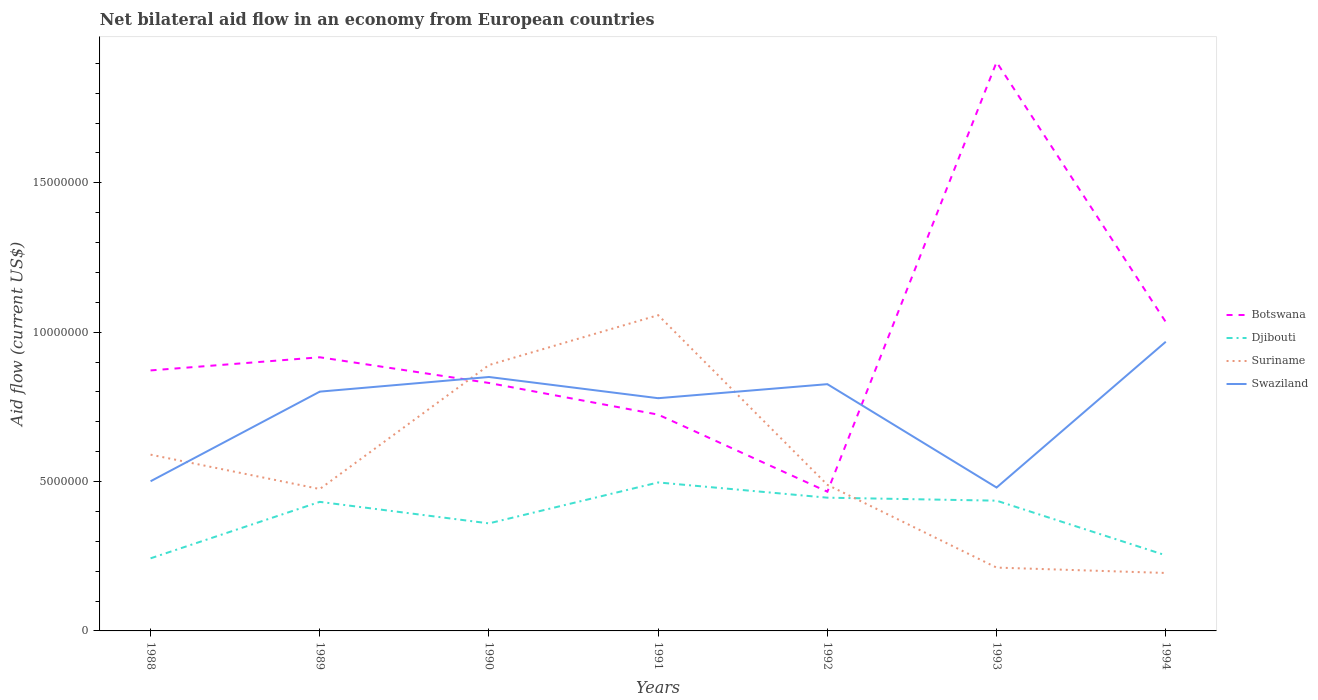How many different coloured lines are there?
Keep it short and to the point. 4. Does the line corresponding to Djibouti intersect with the line corresponding to Suriname?
Offer a terse response. Yes. Across all years, what is the maximum net bilateral aid flow in Suriname?
Offer a terse response. 1.94e+06. What is the total net bilateral aid flow in Djibouti in the graph?
Give a very brief answer. -1.93e+06. What is the difference between the highest and the second highest net bilateral aid flow in Swaziland?
Your answer should be very brief. 4.88e+06. Is the net bilateral aid flow in Djibouti strictly greater than the net bilateral aid flow in Swaziland over the years?
Your answer should be very brief. Yes. How many lines are there?
Offer a terse response. 4. How many years are there in the graph?
Keep it short and to the point. 7. Where does the legend appear in the graph?
Provide a succinct answer. Center right. How many legend labels are there?
Keep it short and to the point. 4. What is the title of the graph?
Make the answer very short. Net bilateral aid flow in an economy from European countries. What is the label or title of the X-axis?
Your answer should be compact. Years. What is the label or title of the Y-axis?
Provide a succinct answer. Aid flow (current US$). What is the Aid flow (current US$) in Botswana in 1988?
Your response must be concise. 8.72e+06. What is the Aid flow (current US$) in Djibouti in 1988?
Keep it short and to the point. 2.43e+06. What is the Aid flow (current US$) of Suriname in 1988?
Keep it short and to the point. 5.90e+06. What is the Aid flow (current US$) in Swaziland in 1988?
Your answer should be very brief. 5.01e+06. What is the Aid flow (current US$) of Botswana in 1989?
Your answer should be very brief. 9.16e+06. What is the Aid flow (current US$) in Djibouti in 1989?
Your response must be concise. 4.32e+06. What is the Aid flow (current US$) in Suriname in 1989?
Give a very brief answer. 4.75e+06. What is the Aid flow (current US$) of Swaziland in 1989?
Give a very brief answer. 8.01e+06. What is the Aid flow (current US$) in Botswana in 1990?
Your answer should be compact. 8.30e+06. What is the Aid flow (current US$) of Djibouti in 1990?
Provide a short and direct response. 3.60e+06. What is the Aid flow (current US$) in Suriname in 1990?
Your response must be concise. 8.90e+06. What is the Aid flow (current US$) of Swaziland in 1990?
Make the answer very short. 8.50e+06. What is the Aid flow (current US$) of Botswana in 1991?
Provide a succinct answer. 7.24e+06. What is the Aid flow (current US$) in Djibouti in 1991?
Offer a very short reply. 4.97e+06. What is the Aid flow (current US$) of Suriname in 1991?
Make the answer very short. 1.06e+07. What is the Aid flow (current US$) of Swaziland in 1991?
Your answer should be compact. 7.79e+06. What is the Aid flow (current US$) of Botswana in 1992?
Provide a short and direct response. 4.66e+06. What is the Aid flow (current US$) of Djibouti in 1992?
Offer a terse response. 4.46e+06. What is the Aid flow (current US$) in Suriname in 1992?
Your response must be concise. 4.89e+06. What is the Aid flow (current US$) of Swaziland in 1992?
Make the answer very short. 8.26e+06. What is the Aid flow (current US$) in Botswana in 1993?
Ensure brevity in your answer.  1.90e+07. What is the Aid flow (current US$) of Djibouti in 1993?
Offer a very short reply. 4.36e+06. What is the Aid flow (current US$) in Suriname in 1993?
Your response must be concise. 2.12e+06. What is the Aid flow (current US$) in Swaziland in 1993?
Give a very brief answer. 4.80e+06. What is the Aid flow (current US$) in Botswana in 1994?
Provide a short and direct response. 1.03e+07. What is the Aid flow (current US$) of Djibouti in 1994?
Give a very brief answer. 2.53e+06. What is the Aid flow (current US$) in Suriname in 1994?
Your answer should be compact. 1.94e+06. What is the Aid flow (current US$) of Swaziland in 1994?
Provide a succinct answer. 9.68e+06. Across all years, what is the maximum Aid flow (current US$) in Botswana?
Your answer should be very brief. 1.90e+07. Across all years, what is the maximum Aid flow (current US$) in Djibouti?
Make the answer very short. 4.97e+06. Across all years, what is the maximum Aid flow (current US$) of Suriname?
Your answer should be very brief. 1.06e+07. Across all years, what is the maximum Aid flow (current US$) in Swaziland?
Provide a short and direct response. 9.68e+06. Across all years, what is the minimum Aid flow (current US$) in Botswana?
Your response must be concise. 4.66e+06. Across all years, what is the minimum Aid flow (current US$) of Djibouti?
Ensure brevity in your answer.  2.43e+06. Across all years, what is the minimum Aid flow (current US$) of Suriname?
Provide a short and direct response. 1.94e+06. Across all years, what is the minimum Aid flow (current US$) in Swaziland?
Provide a succinct answer. 4.80e+06. What is the total Aid flow (current US$) of Botswana in the graph?
Ensure brevity in your answer.  6.75e+07. What is the total Aid flow (current US$) of Djibouti in the graph?
Your response must be concise. 2.67e+07. What is the total Aid flow (current US$) in Suriname in the graph?
Make the answer very short. 3.91e+07. What is the total Aid flow (current US$) in Swaziland in the graph?
Make the answer very short. 5.20e+07. What is the difference between the Aid flow (current US$) in Botswana in 1988 and that in 1989?
Provide a succinct answer. -4.40e+05. What is the difference between the Aid flow (current US$) of Djibouti in 1988 and that in 1989?
Give a very brief answer. -1.89e+06. What is the difference between the Aid flow (current US$) in Suriname in 1988 and that in 1989?
Provide a short and direct response. 1.15e+06. What is the difference between the Aid flow (current US$) of Djibouti in 1988 and that in 1990?
Make the answer very short. -1.17e+06. What is the difference between the Aid flow (current US$) of Suriname in 1988 and that in 1990?
Offer a terse response. -3.00e+06. What is the difference between the Aid flow (current US$) in Swaziland in 1988 and that in 1990?
Ensure brevity in your answer.  -3.49e+06. What is the difference between the Aid flow (current US$) in Botswana in 1988 and that in 1991?
Provide a succinct answer. 1.48e+06. What is the difference between the Aid flow (current US$) in Djibouti in 1988 and that in 1991?
Ensure brevity in your answer.  -2.54e+06. What is the difference between the Aid flow (current US$) in Suriname in 1988 and that in 1991?
Give a very brief answer. -4.67e+06. What is the difference between the Aid flow (current US$) of Swaziland in 1988 and that in 1991?
Keep it short and to the point. -2.78e+06. What is the difference between the Aid flow (current US$) of Botswana in 1988 and that in 1992?
Your answer should be very brief. 4.06e+06. What is the difference between the Aid flow (current US$) in Djibouti in 1988 and that in 1992?
Keep it short and to the point. -2.03e+06. What is the difference between the Aid flow (current US$) of Suriname in 1988 and that in 1992?
Ensure brevity in your answer.  1.01e+06. What is the difference between the Aid flow (current US$) of Swaziland in 1988 and that in 1992?
Provide a short and direct response. -3.25e+06. What is the difference between the Aid flow (current US$) of Botswana in 1988 and that in 1993?
Provide a short and direct response. -1.03e+07. What is the difference between the Aid flow (current US$) in Djibouti in 1988 and that in 1993?
Your answer should be very brief. -1.93e+06. What is the difference between the Aid flow (current US$) of Suriname in 1988 and that in 1993?
Offer a very short reply. 3.78e+06. What is the difference between the Aid flow (current US$) of Swaziland in 1988 and that in 1993?
Your response must be concise. 2.10e+05. What is the difference between the Aid flow (current US$) in Botswana in 1988 and that in 1994?
Give a very brief answer. -1.62e+06. What is the difference between the Aid flow (current US$) in Suriname in 1988 and that in 1994?
Provide a short and direct response. 3.96e+06. What is the difference between the Aid flow (current US$) of Swaziland in 1988 and that in 1994?
Provide a succinct answer. -4.67e+06. What is the difference between the Aid flow (current US$) of Botswana in 1989 and that in 1990?
Provide a short and direct response. 8.60e+05. What is the difference between the Aid flow (current US$) of Djibouti in 1989 and that in 1990?
Your response must be concise. 7.20e+05. What is the difference between the Aid flow (current US$) in Suriname in 1989 and that in 1990?
Offer a very short reply. -4.15e+06. What is the difference between the Aid flow (current US$) in Swaziland in 1989 and that in 1990?
Provide a short and direct response. -4.90e+05. What is the difference between the Aid flow (current US$) in Botswana in 1989 and that in 1991?
Provide a short and direct response. 1.92e+06. What is the difference between the Aid flow (current US$) in Djibouti in 1989 and that in 1991?
Give a very brief answer. -6.50e+05. What is the difference between the Aid flow (current US$) in Suriname in 1989 and that in 1991?
Provide a short and direct response. -5.82e+06. What is the difference between the Aid flow (current US$) in Swaziland in 1989 and that in 1991?
Your response must be concise. 2.20e+05. What is the difference between the Aid flow (current US$) of Botswana in 1989 and that in 1992?
Your answer should be very brief. 4.50e+06. What is the difference between the Aid flow (current US$) in Suriname in 1989 and that in 1992?
Your answer should be compact. -1.40e+05. What is the difference between the Aid flow (current US$) in Swaziland in 1989 and that in 1992?
Your answer should be compact. -2.50e+05. What is the difference between the Aid flow (current US$) in Botswana in 1989 and that in 1993?
Your answer should be very brief. -9.88e+06. What is the difference between the Aid flow (current US$) of Djibouti in 1989 and that in 1993?
Keep it short and to the point. -4.00e+04. What is the difference between the Aid flow (current US$) in Suriname in 1989 and that in 1993?
Keep it short and to the point. 2.63e+06. What is the difference between the Aid flow (current US$) in Swaziland in 1989 and that in 1993?
Offer a very short reply. 3.21e+06. What is the difference between the Aid flow (current US$) of Botswana in 1989 and that in 1994?
Your answer should be very brief. -1.18e+06. What is the difference between the Aid flow (current US$) of Djibouti in 1989 and that in 1994?
Provide a succinct answer. 1.79e+06. What is the difference between the Aid flow (current US$) in Suriname in 1989 and that in 1994?
Make the answer very short. 2.81e+06. What is the difference between the Aid flow (current US$) in Swaziland in 1989 and that in 1994?
Offer a very short reply. -1.67e+06. What is the difference between the Aid flow (current US$) of Botswana in 1990 and that in 1991?
Ensure brevity in your answer.  1.06e+06. What is the difference between the Aid flow (current US$) of Djibouti in 1990 and that in 1991?
Offer a very short reply. -1.37e+06. What is the difference between the Aid flow (current US$) in Suriname in 1990 and that in 1991?
Offer a very short reply. -1.67e+06. What is the difference between the Aid flow (current US$) of Swaziland in 1990 and that in 1991?
Your response must be concise. 7.10e+05. What is the difference between the Aid flow (current US$) of Botswana in 1990 and that in 1992?
Make the answer very short. 3.64e+06. What is the difference between the Aid flow (current US$) in Djibouti in 1990 and that in 1992?
Offer a terse response. -8.60e+05. What is the difference between the Aid flow (current US$) in Suriname in 1990 and that in 1992?
Your response must be concise. 4.01e+06. What is the difference between the Aid flow (current US$) in Swaziland in 1990 and that in 1992?
Offer a terse response. 2.40e+05. What is the difference between the Aid flow (current US$) of Botswana in 1990 and that in 1993?
Give a very brief answer. -1.07e+07. What is the difference between the Aid flow (current US$) of Djibouti in 1990 and that in 1993?
Provide a succinct answer. -7.60e+05. What is the difference between the Aid flow (current US$) of Suriname in 1990 and that in 1993?
Make the answer very short. 6.78e+06. What is the difference between the Aid flow (current US$) of Swaziland in 1990 and that in 1993?
Your answer should be compact. 3.70e+06. What is the difference between the Aid flow (current US$) in Botswana in 1990 and that in 1994?
Offer a very short reply. -2.04e+06. What is the difference between the Aid flow (current US$) in Djibouti in 1990 and that in 1994?
Your answer should be very brief. 1.07e+06. What is the difference between the Aid flow (current US$) in Suriname in 1990 and that in 1994?
Make the answer very short. 6.96e+06. What is the difference between the Aid flow (current US$) in Swaziland in 1990 and that in 1994?
Your answer should be very brief. -1.18e+06. What is the difference between the Aid flow (current US$) of Botswana in 1991 and that in 1992?
Offer a very short reply. 2.58e+06. What is the difference between the Aid flow (current US$) of Djibouti in 1991 and that in 1992?
Offer a very short reply. 5.10e+05. What is the difference between the Aid flow (current US$) of Suriname in 1991 and that in 1992?
Provide a succinct answer. 5.68e+06. What is the difference between the Aid flow (current US$) of Swaziland in 1991 and that in 1992?
Ensure brevity in your answer.  -4.70e+05. What is the difference between the Aid flow (current US$) of Botswana in 1991 and that in 1993?
Keep it short and to the point. -1.18e+07. What is the difference between the Aid flow (current US$) of Djibouti in 1991 and that in 1993?
Offer a terse response. 6.10e+05. What is the difference between the Aid flow (current US$) in Suriname in 1991 and that in 1993?
Keep it short and to the point. 8.45e+06. What is the difference between the Aid flow (current US$) in Swaziland in 1991 and that in 1993?
Keep it short and to the point. 2.99e+06. What is the difference between the Aid flow (current US$) in Botswana in 1991 and that in 1994?
Your response must be concise. -3.10e+06. What is the difference between the Aid flow (current US$) of Djibouti in 1991 and that in 1994?
Provide a short and direct response. 2.44e+06. What is the difference between the Aid flow (current US$) in Suriname in 1991 and that in 1994?
Your answer should be very brief. 8.63e+06. What is the difference between the Aid flow (current US$) of Swaziland in 1991 and that in 1994?
Your response must be concise. -1.89e+06. What is the difference between the Aid flow (current US$) in Botswana in 1992 and that in 1993?
Ensure brevity in your answer.  -1.44e+07. What is the difference between the Aid flow (current US$) in Djibouti in 1992 and that in 1993?
Your answer should be compact. 1.00e+05. What is the difference between the Aid flow (current US$) in Suriname in 1992 and that in 1993?
Your answer should be compact. 2.77e+06. What is the difference between the Aid flow (current US$) of Swaziland in 1992 and that in 1993?
Offer a terse response. 3.46e+06. What is the difference between the Aid flow (current US$) in Botswana in 1992 and that in 1994?
Provide a short and direct response. -5.68e+06. What is the difference between the Aid flow (current US$) of Djibouti in 1992 and that in 1994?
Your answer should be very brief. 1.93e+06. What is the difference between the Aid flow (current US$) in Suriname in 1992 and that in 1994?
Make the answer very short. 2.95e+06. What is the difference between the Aid flow (current US$) in Swaziland in 1992 and that in 1994?
Keep it short and to the point. -1.42e+06. What is the difference between the Aid flow (current US$) in Botswana in 1993 and that in 1994?
Your response must be concise. 8.70e+06. What is the difference between the Aid flow (current US$) of Djibouti in 1993 and that in 1994?
Your answer should be very brief. 1.83e+06. What is the difference between the Aid flow (current US$) of Suriname in 1993 and that in 1994?
Offer a terse response. 1.80e+05. What is the difference between the Aid flow (current US$) in Swaziland in 1993 and that in 1994?
Ensure brevity in your answer.  -4.88e+06. What is the difference between the Aid flow (current US$) in Botswana in 1988 and the Aid flow (current US$) in Djibouti in 1989?
Provide a succinct answer. 4.40e+06. What is the difference between the Aid flow (current US$) in Botswana in 1988 and the Aid flow (current US$) in Suriname in 1989?
Your answer should be compact. 3.97e+06. What is the difference between the Aid flow (current US$) of Botswana in 1988 and the Aid flow (current US$) of Swaziland in 1989?
Provide a succinct answer. 7.10e+05. What is the difference between the Aid flow (current US$) of Djibouti in 1988 and the Aid flow (current US$) of Suriname in 1989?
Provide a short and direct response. -2.32e+06. What is the difference between the Aid flow (current US$) of Djibouti in 1988 and the Aid flow (current US$) of Swaziland in 1989?
Your response must be concise. -5.58e+06. What is the difference between the Aid flow (current US$) of Suriname in 1988 and the Aid flow (current US$) of Swaziland in 1989?
Offer a very short reply. -2.11e+06. What is the difference between the Aid flow (current US$) of Botswana in 1988 and the Aid flow (current US$) of Djibouti in 1990?
Your answer should be very brief. 5.12e+06. What is the difference between the Aid flow (current US$) in Botswana in 1988 and the Aid flow (current US$) in Swaziland in 1990?
Your answer should be compact. 2.20e+05. What is the difference between the Aid flow (current US$) in Djibouti in 1988 and the Aid flow (current US$) in Suriname in 1990?
Make the answer very short. -6.47e+06. What is the difference between the Aid flow (current US$) of Djibouti in 1988 and the Aid flow (current US$) of Swaziland in 1990?
Your answer should be compact. -6.07e+06. What is the difference between the Aid flow (current US$) in Suriname in 1988 and the Aid flow (current US$) in Swaziland in 1990?
Give a very brief answer. -2.60e+06. What is the difference between the Aid flow (current US$) in Botswana in 1988 and the Aid flow (current US$) in Djibouti in 1991?
Keep it short and to the point. 3.75e+06. What is the difference between the Aid flow (current US$) in Botswana in 1988 and the Aid flow (current US$) in Suriname in 1991?
Keep it short and to the point. -1.85e+06. What is the difference between the Aid flow (current US$) in Botswana in 1988 and the Aid flow (current US$) in Swaziland in 1991?
Your response must be concise. 9.30e+05. What is the difference between the Aid flow (current US$) in Djibouti in 1988 and the Aid flow (current US$) in Suriname in 1991?
Your response must be concise. -8.14e+06. What is the difference between the Aid flow (current US$) in Djibouti in 1988 and the Aid flow (current US$) in Swaziland in 1991?
Your response must be concise. -5.36e+06. What is the difference between the Aid flow (current US$) in Suriname in 1988 and the Aid flow (current US$) in Swaziland in 1991?
Provide a succinct answer. -1.89e+06. What is the difference between the Aid flow (current US$) in Botswana in 1988 and the Aid flow (current US$) in Djibouti in 1992?
Your answer should be compact. 4.26e+06. What is the difference between the Aid flow (current US$) in Botswana in 1988 and the Aid flow (current US$) in Suriname in 1992?
Your answer should be very brief. 3.83e+06. What is the difference between the Aid flow (current US$) in Djibouti in 1988 and the Aid flow (current US$) in Suriname in 1992?
Ensure brevity in your answer.  -2.46e+06. What is the difference between the Aid flow (current US$) of Djibouti in 1988 and the Aid flow (current US$) of Swaziland in 1992?
Offer a terse response. -5.83e+06. What is the difference between the Aid flow (current US$) in Suriname in 1988 and the Aid flow (current US$) in Swaziland in 1992?
Provide a succinct answer. -2.36e+06. What is the difference between the Aid flow (current US$) in Botswana in 1988 and the Aid flow (current US$) in Djibouti in 1993?
Your answer should be compact. 4.36e+06. What is the difference between the Aid flow (current US$) of Botswana in 1988 and the Aid flow (current US$) of Suriname in 1993?
Provide a succinct answer. 6.60e+06. What is the difference between the Aid flow (current US$) of Botswana in 1988 and the Aid flow (current US$) of Swaziland in 1993?
Provide a succinct answer. 3.92e+06. What is the difference between the Aid flow (current US$) in Djibouti in 1988 and the Aid flow (current US$) in Swaziland in 1993?
Offer a terse response. -2.37e+06. What is the difference between the Aid flow (current US$) of Suriname in 1988 and the Aid flow (current US$) of Swaziland in 1993?
Your answer should be compact. 1.10e+06. What is the difference between the Aid flow (current US$) in Botswana in 1988 and the Aid flow (current US$) in Djibouti in 1994?
Offer a very short reply. 6.19e+06. What is the difference between the Aid flow (current US$) of Botswana in 1988 and the Aid flow (current US$) of Suriname in 1994?
Your response must be concise. 6.78e+06. What is the difference between the Aid flow (current US$) of Botswana in 1988 and the Aid flow (current US$) of Swaziland in 1994?
Offer a very short reply. -9.60e+05. What is the difference between the Aid flow (current US$) of Djibouti in 1988 and the Aid flow (current US$) of Suriname in 1994?
Offer a very short reply. 4.90e+05. What is the difference between the Aid flow (current US$) in Djibouti in 1988 and the Aid flow (current US$) in Swaziland in 1994?
Provide a succinct answer. -7.25e+06. What is the difference between the Aid flow (current US$) of Suriname in 1988 and the Aid flow (current US$) of Swaziland in 1994?
Keep it short and to the point. -3.78e+06. What is the difference between the Aid flow (current US$) in Botswana in 1989 and the Aid flow (current US$) in Djibouti in 1990?
Provide a succinct answer. 5.56e+06. What is the difference between the Aid flow (current US$) in Botswana in 1989 and the Aid flow (current US$) in Suriname in 1990?
Your answer should be compact. 2.60e+05. What is the difference between the Aid flow (current US$) of Botswana in 1989 and the Aid flow (current US$) of Swaziland in 1990?
Ensure brevity in your answer.  6.60e+05. What is the difference between the Aid flow (current US$) in Djibouti in 1989 and the Aid flow (current US$) in Suriname in 1990?
Your answer should be compact. -4.58e+06. What is the difference between the Aid flow (current US$) in Djibouti in 1989 and the Aid flow (current US$) in Swaziland in 1990?
Ensure brevity in your answer.  -4.18e+06. What is the difference between the Aid flow (current US$) in Suriname in 1989 and the Aid flow (current US$) in Swaziland in 1990?
Make the answer very short. -3.75e+06. What is the difference between the Aid flow (current US$) in Botswana in 1989 and the Aid flow (current US$) in Djibouti in 1991?
Offer a terse response. 4.19e+06. What is the difference between the Aid flow (current US$) of Botswana in 1989 and the Aid flow (current US$) of Suriname in 1991?
Give a very brief answer. -1.41e+06. What is the difference between the Aid flow (current US$) of Botswana in 1989 and the Aid flow (current US$) of Swaziland in 1991?
Offer a very short reply. 1.37e+06. What is the difference between the Aid flow (current US$) in Djibouti in 1989 and the Aid flow (current US$) in Suriname in 1991?
Ensure brevity in your answer.  -6.25e+06. What is the difference between the Aid flow (current US$) in Djibouti in 1989 and the Aid flow (current US$) in Swaziland in 1991?
Your answer should be compact. -3.47e+06. What is the difference between the Aid flow (current US$) of Suriname in 1989 and the Aid flow (current US$) of Swaziland in 1991?
Ensure brevity in your answer.  -3.04e+06. What is the difference between the Aid flow (current US$) of Botswana in 1989 and the Aid flow (current US$) of Djibouti in 1992?
Provide a short and direct response. 4.70e+06. What is the difference between the Aid flow (current US$) in Botswana in 1989 and the Aid flow (current US$) in Suriname in 1992?
Keep it short and to the point. 4.27e+06. What is the difference between the Aid flow (current US$) of Djibouti in 1989 and the Aid flow (current US$) of Suriname in 1992?
Ensure brevity in your answer.  -5.70e+05. What is the difference between the Aid flow (current US$) in Djibouti in 1989 and the Aid flow (current US$) in Swaziland in 1992?
Your answer should be very brief. -3.94e+06. What is the difference between the Aid flow (current US$) in Suriname in 1989 and the Aid flow (current US$) in Swaziland in 1992?
Keep it short and to the point. -3.51e+06. What is the difference between the Aid flow (current US$) of Botswana in 1989 and the Aid flow (current US$) of Djibouti in 1993?
Provide a short and direct response. 4.80e+06. What is the difference between the Aid flow (current US$) in Botswana in 1989 and the Aid flow (current US$) in Suriname in 1993?
Your answer should be very brief. 7.04e+06. What is the difference between the Aid flow (current US$) of Botswana in 1989 and the Aid flow (current US$) of Swaziland in 1993?
Offer a terse response. 4.36e+06. What is the difference between the Aid flow (current US$) of Djibouti in 1989 and the Aid flow (current US$) of Suriname in 1993?
Your answer should be compact. 2.20e+06. What is the difference between the Aid flow (current US$) in Djibouti in 1989 and the Aid flow (current US$) in Swaziland in 1993?
Give a very brief answer. -4.80e+05. What is the difference between the Aid flow (current US$) of Suriname in 1989 and the Aid flow (current US$) of Swaziland in 1993?
Make the answer very short. -5.00e+04. What is the difference between the Aid flow (current US$) of Botswana in 1989 and the Aid flow (current US$) of Djibouti in 1994?
Offer a terse response. 6.63e+06. What is the difference between the Aid flow (current US$) of Botswana in 1989 and the Aid flow (current US$) of Suriname in 1994?
Keep it short and to the point. 7.22e+06. What is the difference between the Aid flow (current US$) in Botswana in 1989 and the Aid flow (current US$) in Swaziland in 1994?
Your response must be concise. -5.20e+05. What is the difference between the Aid flow (current US$) in Djibouti in 1989 and the Aid flow (current US$) in Suriname in 1994?
Make the answer very short. 2.38e+06. What is the difference between the Aid flow (current US$) of Djibouti in 1989 and the Aid flow (current US$) of Swaziland in 1994?
Your response must be concise. -5.36e+06. What is the difference between the Aid flow (current US$) in Suriname in 1989 and the Aid flow (current US$) in Swaziland in 1994?
Offer a very short reply. -4.93e+06. What is the difference between the Aid flow (current US$) of Botswana in 1990 and the Aid flow (current US$) of Djibouti in 1991?
Offer a terse response. 3.33e+06. What is the difference between the Aid flow (current US$) in Botswana in 1990 and the Aid flow (current US$) in Suriname in 1991?
Keep it short and to the point. -2.27e+06. What is the difference between the Aid flow (current US$) of Botswana in 1990 and the Aid flow (current US$) of Swaziland in 1991?
Ensure brevity in your answer.  5.10e+05. What is the difference between the Aid flow (current US$) in Djibouti in 1990 and the Aid flow (current US$) in Suriname in 1991?
Provide a short and direct response. -6.97e+06. What is the difference between the Aid flow (current US$) of Djibouti in 1990 and the Aid flow (current US$) of Swaziland in 1991?
Offer a terse response. -4.19e+06. What is the difference between the Aid flow (current US$) of Suriname in 1990 and the Aid flow (current US$) of Swaziland in 1991?
Your response must be concise. 1.11e+06. What is the difference between the Aid flow (current US$) in Botswana in 1990 and the Aid flow (current US$) in Djibouti in 1992?
Your response must be concise. 3.84e+06. What is the difference between the Aid flow (current US$) of Botswana in 1990 and the Aid flow (current US$) of Suriname in 1992?
Make the answer very short. 3.41e+06. What is the difference between the Aid flow (current US$) of Djibouti in 1990 and the Aid flow (current US$) of Suriname in 1992?
Make the answer very short. -1.29e+06. What is the difference between the Aid flow (current US$) of Djibouti in 1990 and the Aid flow (current US$) of Swaziland in 1992?
Your answer should be compact. -4.66e+06. What is the difference between the Aid flow (current US$) in Suriname in 1990 and the Aid flow (current US$) in Swaziland in 1992?
Provide a succinct answer. 6.40e+05. What is the difference between the Aid flow (current US$) of Botswana in 1990 and the Aid flow (current US$) of Djibouti in 1993?
Offer a terse response. 3.94e+06. What is the difference between the Aid flow (current US$) in Botswana in 1990 and the Aid flow (current US$) in Suriname in 1993?
Give a very brief answer. 6.18e+06. What is the difference between the Aid flow (current US$) of Botswana in 1990 and the Aid flow (current US$) of Swaziland in 1993?
Ensure brevity in your answer.  3.50e+06. What is the difference between the Aid flow (current US$) of Djibouti in 1990 and the Aid flow (current US$) of Suriname in 1993?
Your answer should be compact. 1.48e+06. What is the difference between the Aid flow (current US$) of Djibouti in 1990 and the Aid flow (current US$) of Swaziland in 1993?
Provide a short and direct response. -1.20e+06. What is the difference between the Aid flow (current US$) of Suriname in 1990 and the Aid flow (current US$) of Swaziland in 1993?
Provide a succinct answer. 4.10e+06. What is the difference between the Aid flow (current US$) in Botswana in 1990 and the Aid flow (current US$) in Djibouti in 1994?
Keep it short and to the point. 5.77e+06. What is the difference between the Aid flow (current US$) of Botswana in 1990 and the Aid flow (current US$) of Suriname in 1994?
Make the answer very short. 6.36e+06. What is the difference between the Aid flow (current US$) of Botswana in 1990 and the Aid flow (current US$) of Swaziland in 1994?
Your response must be concise. -1.38e+06. What is the difference between the Aid flow (current US$) in Djibouti in 1990 and the Aid flow (current US$) in Suriname in 1994?
Offer a terse response. 1.66e+06. What is the difference between the Aid flow (current US$) of Djibouti in 1990 and the Aid flow (current US$) of Swaziland in 1994?
Provide a short and direct response. -6.08e+06. What is the difference between the Aid flow (current US$) of Suriname in 1990 and the Aid flow (current US$) of Swaziland in 1994?
Provide a succinct answer. -7.80e+05. What is the difference between the Aid flow (current US$) of Botswana in 1991 and the Aid flow (current US$) of Djibouti in 1992?
Offer a very short reply. 2.78e+06. What is the difference between the Aid flow (current US$) in Botswana in 1991 and the Aid flow (current US$) in Suriname in 1992?
Provide a succinct answer. 2.35e+06. What is the difference between the Aid flow (current US$) of Botswana in 1991 and the Aid flow (current US$) of Swaziland in 1992?
Your response must be concise. -1.02e+06. What is the difference between the Aid flow (current US$) in Djibouti in 1991 and the Aid flow (current US$) in Suriname in 1992?
Give a very brief answer. 8.00e+04. What is the difference between the Aid flow (current US$) of Djibouti in 1991 and the Aid flow (current US$) of Swaziland in 1992?
Offer a very short reply. -3.29e+06. What is the difference between the Aid flow (current US$) of Suriname in 1991 and the Aid flow (current US$) of Swaziland in 1992?
Give a very brief answer. 2.31e+06. What is the difference between the Aid flow (current US$) of Botswana in 1991 and the Aid flow (current US$) of Djibouti in 1993?
Your answer should be very brief. 2.88e+06. What is the difference between the Aid flow (current US$) of Botswana in 1991 and the Aid flow (current US$) of Suriname in 1993?
Keep it short and to the point. 5.12e+06. What is the difference between the Aid flow (current US$) of Botswana in 1991 and the Aid flow (current US$) of Swaziland in 1993?
Keep it short and to the point. 2.44e+06. What is the difference between the Aid flow (current US$) of Djibouti in 1991 and the Aid flow (current US$) of Suriname in 1993?
Your answer should be compact. 2.85e+06. What is the difference between the Aid flow (current US$) in Djibouti in 1991 and the Aid flow (current US$) in Swaziland in 1993?
Your answer should be very brief. 1.70e+05. What is the difference between the Aid flow (current US$) in Suriname in 1991 and the Aid flow (current US$) in Swaziland in 1993?
Your response must be concise. 5.77e+06. What is the difference between the Aid flow (current US$) of Botswana in 1991 and the Aid flow (current US$) of Djibouti in 1994?
Keep it short and to the point. 4.71e+06. What is the difference between the Aid flow (current US$) of Botswana in 1991 and the Aid flow (current US$) of Suriname in 1994?
Keep it short and to the point. 5.30e+06. What is the difference between the Aid flow (current US$) of Botswana in 1991 and the Aid flow (current US$) of Swaziland in 1994?
Your response must be concise. -2.44e+06. What is the difference between the Aid flow (current US$) in Djibouti in 1991 and the Aid flow (current US$) in Suriname in 1994?
Offer a very short reply. 3.03e+06. What is the difference between the Aid flow (current US$) of Djibouti in 1991 and the Aid flow (current US$) of Swaziland in 1994?
Ensure brevity in your answer.  -4.71e+06. What is the difference between the Aid flow (current US$) in Suriname in 1991 and the Aid flow (current US$) in Swaziland in 1994?
Offer a terse response. 8.90e+05. What is the difference between the Aid flow (current US$) of Botswana in 1992 and the Aid flow (current US$) of Suriname in 1993?
Offer a very short reply. 2.54e+06. What is the difference between the Aid flow (current US$) in Botswana in 1992 and the Aid flow (current US$) in Swaziland in 1993?
Your response must be concise. -1.40e+05. What is the difference between the Aid flow (current US$) of Djibouti in 1992 and the Aid flow (current US$) of Suriname in 1993?
Ensure brevity in your answer.  2.34e+06. What is the difference between the Aid flow (current US$) of Djibouti in 1992 and the Aid flow (current US$) of Swaziland in 1993?
Offer a very short reply. -3.40e+05. What is the difference between the Aid flow (current US$) of Suriname in 1992 and the Aid flow (current US$) of Swaziland in 1993?
Give a very brief answer. 9.00e+04. What is the difference between the Aid flow (current US$) in Botswana in 1992 and the Aid flow (current US$) in Djibouti in 1994?
Provide a short and direct response. 2.13e+06. What is the difference between the Aid flow (current US$) of Botswana in 1992 and the Aid flow (current US$) of Suriname in 1994?
Your answer should be very brief. 2.72e+06. What is the difference between the Aid flow (current US$) of Botswana in 1992 and the Aid flow (current US$) of Swaziland in 1994?
Your response must be concise. -5.02e+06. What is the difference between the Aid flow (current US$) in Djibouti in 1992 and the Aid flow (current US$) in Suriname in 1994?
Offer a very short reply. 2.52e+06. What is the difference between the Aid flow (current US$) of Djibouti in 1992 and the Aid flow (current US$) of Swaziland in 1994?
Keep it short and to the point. -5.22e+06. What is the difference between the Aid flow (current US$) in Suriname in 1992 and the Aid flow (current US$) in Swaziland in 1994?
Your answer should be compact. -4.79e+06. What is the difference between the Aid flow (current US$) of Botswana in 1993 and the Aid flow (current US$) of Djibouti in 1994?
Provide a succinct answer. 1.65e+07. What is the difference between the Aid flow (current US$) of Botswana in 1993 and the Aid flow (current US$) of Suriname in 1994?
Offer a very short reply. 1.71e+07. What is the difference between the Aid flow (current US$) of Botswana in 1993 and the Aid flow (current US$) of Swaziland in 1994?
Your answer should be very brief. 9.36e+06. What is the difference between the Aid flow (current US$) of Djibouti in 1993 and the Aid flow (current US$) of Suriname in 1994?
Give a very brief answer. 2.42e+06. What is the difference between the Aid flow (current US$) of Djibouti in 1993 and the Aid flow (current US$) of Swaziland in 1994?
Give a very brief answer. -5.32e+06. What is the difference between the Aid flow (current US$) of Suriname in 1993 and the Aid flow (current US$) of Swaziland in 1994?
Offer a very short reply. -7.56e+06. What is the average Aid flow (current US$) in Botswana per year?
Make the answer very short. 9.64e+06. What is the average Aid flow (current US$) in Djibouti per year?
Provide a succinct answer. 3.81e+06. What is the average Aid flow (current US$) of Suriname per year?
Keep it short and to the point. 5.58e+06. What is the average Aid flow (current US$) of Swaziland per year?
Your answer should be compact. 7.44e+06. In the year 1988, what is the difference between the Aid flow (current US$) in Botswana and Aid flow (current US$) in Djibouti?
Give a very brief answer. 6.29e+06. In the year 1988, what is the difference between the Aid flow (current US$) in Botswana and Aid flow (current US$) in Suriname?
Your answer should be very brief. 2.82e+06. In the year 1988, what is the difference between the Aid flow (current US$) of Botswana and Aid flow (current US$) of Swaziland?
Your response must be concise. 3.71e+06. In the year 1988, what is the difference between the Aid flow (current US$) of Djibouti and Aid flow (current US$) of Suriname?
Your answer should be compact. -3.47e+06. In the year 1988, what is the difference between the Aid flow (current US$) of Djibouti and Aid flow (current US$) of Swaziland?
Provide a succinct answer. -2.58e+06. In the year 1988, what is the difference between the Aid flow (current US$) in Suriname and Aid flow (current US$) in Swaziland?
Offer a terse response. 8.90e+05. In the year 1989, what is the difference between the Aid flow (current US$) of Botswana and Aid flow (current US$) of Djibouti?
Offer a terse response. 4.84e+06. In the year 1989, what is the difference between the Aid flow (current US$) of Botswana and Aid flow (current US$) of Suriname?
Your answer should be very brief. 4.41e+06. In the year 1989, what is the difference between the Aid flow (current US$) of Botswana and Aid flow (current US$) of Swaziland?
Your answer should be compact. 1.15e+06. In the year 1989, what is the difference between the Aid flow (current US$) of Djibouti and Aid flow (current US$) of Suriname?
Provide a succinct answer. -4.30e+05. In the year 1989, what is the difference between the Aid flow (current US$) in Djibouti and Aid flow (current US$) in Swaziland?
Give a very brief answer. -3.69e+06. In the year 1989, what is the difference between the Aid flow (current US$) of Suriname and Aid flow (current US$) of Swaziland?
Give a very brief answer. -3.26e+06. In the year 1990, what is the difference between the Aid flow (current US$) of Botswana and Aid flow (current US$) of Djibouti?
Your answer should be compact. 4.70e+06. In the year 1990, what is the difference between the Aid flow (current US$) of Botswana and Aid flow (current US$) of Suriname?
Provide a short and direct response. -6.00e+05. In the year 1990, what is the difference between the Aid flow (current US$) of Botswana and Aid flow (current US$) of Swaziland?
Give a very brief answer. -2.00e+05. In the year 1990, what is the difference between the Aid flow (current US$) in Djibouti and Aid flow (current US$) in Suriname?
Your response must be concise. -5.30e+06. In the year 1990, what is the difference between the Aid flow (current US$) in Djibouti and Aid flow (current US$) in Swaziland?
Keep it short and to the point. -4.90e+06. In the year 1990, what is the difference between the Aid flow (current US$) of Suriname and Aid flow (current US$) of Swaziland?
Your answer should be very brief. 4.00e+05. In the year 1991, what is the difference between the Aid flow (current US$) of Botswana and Aid flow (current US$) of Djibouti?
Provide a short and direct response. 2.27e+06. In the year 1991, what is the difference between the Aid flow (current US$) of Botswana and Aid flow (current US$) of Suriname?
Provide a succinct answer. -3.33e+06. In the year 1991, what is the difference between the Aid flow (current US$) in Botswana and Aid flow (current US$) in Swaziland?
Provide a succinct answer. -5.50e+05. In the year 1991, what is the difference between the Aid flow (current US$) of Djibouti and Aid flow (current US$) of Suriname?
Your response must be concise. -5.60e+06. In the year 1991, what is the difference between the Aid flow (current US$) of Djibouti and Aid flow (current US$) of Swaziland?
Your response must be concise. -2.82e+06. In the year 1991, what is the difference between the Aid flow (current US$) of Suriname and Aid flow (current US$) of Swaziland?
Your answer should be compact. 2.78e+06. In the year 1992, what is the difference between the Aid flow (current US$) in Botswana and Aid flow (current US$) in Suriname?
Your response must be concise. -2.30e+05. In the year 1992, what is the difference between the Aid flow (current US$) of Botswana and Aid flow (current US$) of Swaziland?
Ensure brevity in your answer.  -3.60e+06. In the year 1992, what is the difference between the Aid flow (current US$) in Djibouti and Aid flow (current US$) in Suriname?
Give a very brief answer. -4.30e+05. In the year 1992, what is the difference between the Aid flow (current US$) of Djibouti and Aid flow (current US$) of Swaziland?
Your answer should be very brief. -3.80e+06. In the year 1992, what is the difference between the Aid flow (current US$) in Suriname and Aid flow (current US$) in Swaziland?
Give a very brief answer. -3.37e+06. In the year 1993, what is the difference between the Aid flow (current US$) in Botswana and Aid flow (current US$) in Djibouti?
Your response must be concise. 1.47e+07. In the year 1993, what is the difference between the Aid flow (current US$) of Botswana and Aid flow (current US$) of Suriname?
Your response must be concise. 1.69e+07. In the year 1993, what is the difference between the Aid flow (current US$) in Botswana and Aid flow (current US$) in Swaziland?
Keep it short and to the point. 1.42e+07. In the year 1993, what is the difference between the Aid flow (current US$) in Djibouti and Aid flow (current US$) in Suriname?
Your answer should be compact. 2.24e+06. In the year 1993, what is the difference between the Aid flow (current US$) of Djibouti and Aid flow (current US$) of Swaziland?
Provide a short and direct response. -4.40e+05. In the year 1993, what is the difference between the Aid flow (current US$) in Suriname and Aid flow (current US$) in Swaziland?
Keep it short and to the point. -2.68e+06. In the year 1994, what is the difference between the Aid flow (current US$) of Botswana and Aid flow (current US$) of Djibouti?
Give a very brief answer. 7.81e+06. In the year 1994, what is the difference between the Aid flow (current US$) in Botswana and Aid flow (current US$) in Suriname?
Your response must be concise. 8.40e+06. In the year 1994, what is the difference between the Aid flow (current US$) of Djibouti and Aid flow (current US$) of Suriname?
Provide a succinct answer. 5.90e+05. In the year 1994, what is the difference between the Aid flow (current US$) in Djibouti and Aid flow (current US$) in Swaziland?
Ensure brevity in your answer.  -7.15e+06. In the year 1994, what is the difference between the Aid flow (current US$) in Suriname and Aid flow (current US$) in Swaziland?
Provide a short and direct response. -7.74e+06. What is the ratio of the Aid flow (current US$) in Djibouti in 1988 to that in 1989?
Ensure brevity in your answer.  0.56. What is the ratio of the Aid flow (current US$) of Suriname in 1988 to that in 1989?
Give a very brief answer. 1.24. What is the ratio of the Aid flow (current US$) of Swaziland in 1988 to that in 1989?
Provide a short and direct response. 0.63. What is the ratio of the Aid flow (current US$) in Botswana in 1988 to that in 1990?
Your response must be concise. 1.05. What is the ratio of the Aid flow (current US$) of Djibouti in 1988 to that in 1990?
Make the answer very short. 0.68. What is the ratio of the Aid flow (current US$) in Suriname in 1988 to that in 1990?
Offer a very short reply. 0.66. What is the ratio of the Aid flow (current US$) of Swaziland in 1988 to that in 1990?
Offer a terse response. 0.59. What is the ratio of the Aid flow (current US$) of Botswana in 1988 to that in 1991?
Offer a very short reply. 1.2. What is the ratio of the Aid flow (current US$) of Djibouti in 1988 to that in 1991?
Keep it short and to the point. 0.49. What is the ratio of the Aid flow (current US$) in Suriname in 1988 to that in 1991?
Provide a succinct answer. 0.56. What is the ratio of the Aid flow (current US$) in Swaziland in 1988 to that in 1991?
Offer a very short reply. 0.64. What is the ratio of the Aid flow (current US$) of Botswana in 1988 to that in 1992?
Offer a very short reply. 1.87. What is the ratio of the Aid flow (current US$) in Djibouti in 1988 to that in 1992?
Make the answer very short. 0.54. What is the ratio of the Aid flow (current US$) in Suriname in 1988 to that in 1992?
Your answer should be very brief. 1.21. What is the ratio of the Aid flow (current US$) in Swaziland in 1988 to that in 1992?
Your response must be concise. 0.61. What is the ratio of the Aid flow (current US$) of Botswana in 1988 to that in 1993?
Offer a very short reply. 0.46. What is the ratio of the Aid flow (current US$) of Djibouti in 1988 to that in 1993?
Offer a very short reply. 0.56. What is the ratio of the Aid flow (current US$) of Suriname in 1988 to that in 1993?
Offer a very short reply. 2.78. What is the ratio of the Aid flow (current US$) in Swaziland in 1988 to that in 1993?
Provide a succinct answer. 1.04. What is the ratio of the Aid flow (current US$) of Botswana in 1988 to that in 1994?
Provide a short and direct response. 0.84. What is the ratio of the Aid flow (current US$) of Djibouti in 1988 to that in 1994?
Offer a terse response. 0.96. What is the ratio of the Aid flow (current US$) of Suriname in 1988 to that in 1994?
Make the answer very short. 3.04. What is the ratio of the Aid flow (current US$) of Swaziland in 1988 to that in 1994?
Ensure brevity in your answer.  0.52. What is the ratio of the Aid flow (current US$) in Botswana in 1989 to that in 1990?
Offer a terse response. 1.1. What is the ratio of the Aid flow (current US$) of Suriname in 1989 to that in 1990?
Give a very brief answer. 0.53. What is the ratio of the Aid flow (current US$) in Swaziland in 1989 to that in 1990?
Offer a very short reply. 0.94. What is the ratio of the Aid flow (current US$) in Botswana in 1989 to that in 1991?
Give a very brief answer. 1.27. What is the ratio of the Aid flow (current US$) in Djibouti in 1989 to that in 1991?
Provide a short and direct response. 0.87. What is the ratio of the Aid flow (current US$) in Suriname in 1989 to that in 1991?
Ensure brevity in your answer.  0.45. What is the ratio of the Aid flow (current US$) in Swaziland in 1989 to that in 1991?
Offer a terse response. 1.03. What is the ratio of the Aid flow (current US$) in Botswana in 1989 to that in 1992?
Your answer should be very brief. 1.97. What is the ratio of the Aid flow (current US$) in Djibouti in 1989 to that in 1992?
Your response must be concise. 0.97. What is the ratio of the Aid flow (current US$) in Suriname in 1989 to that in 1992?
Offer a very short reply. 0.97. What is the ratio of the Aid flow (current US$) of Swaziland in 1989 to that in 1992?
Make the answer very short. 0.97. What is the ratio of the Aid flow (current US$) of Botswana in 1989 to that in 1993?
Keep it short and to the point. 0.48. What is the ratio of the Aid flow (current US$) of Djibouti in 1989 to that in 1993?
Provide a succinct answer. 0.99. What is the ratio of the Aid flow (current US$) of Suriname in 1989 to that in 1993?
Your response must be concise. 2.24. What is the ratio of the Aid flow (current US$) in Swaziland in 1989 to that in 1993?
Make the answer very short. 1.67. What is the ratio of the Aid flow (current US$) of Botswana in 1989 to that in 1994?
Keep it short and to the point. 0.89. What is the ratio of the Aid flow (current US$) in Djibouti in 1989 to that in 1994?
Give a very brief answer. 1.71. What is the ratio of the Aid flow (current US$) in Suriname in 1989 to that in 1994?
Give a very brief answer. 2.45. What is the ratio of the Aid flow (current US$) of Swaziland in 1989 to that in 1994?
Offer a very short reply. 0.83. What is the ratio of the Aid flow (current US$) of Botswana in 1990 to that in 1991?
Keep it short and to the point. 1.15. What is the ratio of the Aid flow (current US$) in Djibouti in 1990 to that in 1991?
Your answer should be very brief. 0.72. What is the ratio of the Aid flow (current US$) of Suriname in 1990 to that in 1991?
Provide a succinct answer. 0.84. What is the ratio of the Aid flow (current US$) of Swaziland in 1990 to that in 1991?
Your response must be concise. 1.09. What is the ratio of the Aid flow (current US$) of Botswana in 1990 to that in 1992?
Ensure brevity in your answer.  1.78. What is the ratio of the Aid flow (current US$) in Djibouti in 1990 to that in 1992?
Provide a succinct answer. 0.81. What is the ratio of the Aid flow (current US$) in Suriname in 1990 to that in 1992?
Give a very brief answer. 1.82. What is the ratio of the Aid flow (current US$) in Swaziland in 1990 to that in 1992?
Keep it short and to the point. 1.03. What is the ratio of the Aid flow (current US$) of Botswana in 1990 to that in 1993?
Your response must be concise. 0.44. What is the ratio of the Aid flow (current US$) in Djibouti in 1990 to that in 1993?
Your answer should be very brief. 0.83. What is the ratio of the Aid flow (current US$) in Suriname in 1990 to that in 1993?
Your answer should be compact. 4.2. What is the ratio of the Aid flow (current US$) in Swaziland in 1990 to that in 1993?
Offer a very short reply. 1.77. What is the ratio of the Aid flow (current US$) in Botswana in 1990 to that in 1994?
Give a very brief answer. 0.8. What is the ratio of the Aid flow (current US$) in Djibouti in 1990 to that in 1994?
Your answer should be compact. 1.42. What is the ratio of the Aid flow (current US$) of Suriname in 1990 to that in 1994?
Offer a terse response. 4.59. What is the ratio of the Aid flow (current US$) of Swaziland in 1990 to that in 1994?
Make the answer very short. 0.88. What is the ratio of the Aid flow (current US$) of Botswana in 1991 to that in 1992?
Provide a short and direct response. 1.55. What is the ratio of the Aid flow (current US$) of Djibouti in 1991 to that in 1992?
Offer a very short reply. 1.11. What is the ratio of the Aid flow (current US$) in Suriname in 1991 to that in 1992?
Make the answer very short. 2.16. What is the ratio of the Aid flow (current US$) in Swaziland in 1991 to that in 1992?
Your answer should be compact. 0.94. What is the ratio of the Aid flow (current US$) of Botswana in 1991 to that in 1993?
Offer a terse response. 0.38. What is the ratio of the Aid flow (current US$) in Djibouti in 1991 to that in 1993?
Your response must be concise. 1.14. What is the ratio of the Aid flow (current US$) of Suriname in 1991 to that in 1993?
Your answer should be very brief. 4.99. What is the ratio of the Aid flow (current US$) of Swaziland in 1991 to that in 1993?
Your response must be concise. 1.62. What is the ratio of the Aid flow (current US$) of Botswana in 1991 to that in 1994?
Ensure brevity in your answer.  0.7. What is the ratio of the Aid flow (current US$) of Djibouti in 1991 to that in 1994?
Give a very brief answer. 1.96. What is the ratio of the Aid flow (current US$) of Suriname in 1991 to that in 1994?
Offer a very short reply. 5.45. What is the ratio of the Aid flow (current US$) in Swaziland in 1991 to that in 1994?
Offer a very short reply. 0.8. What is the ratio of the Aid flow (current US$) in Botswana in 1992 to that in 1993?
Your answer should be very brief. 0.24. What is the ratio of the Aid flow (current US$) of Djibouti in 1992 to that in 1993?
Provide a short and direct response. 1.02. What is the ratio of the Aid flow (current US$) in Suriname in 1992 to that in 1993?
Make the answer very short. 2.31. What is the ratio of the Aid flow (current US$) of Swaziland in 1992 to that in 1993?
Make the answer very short. 1.72. What is the ratio of the Aid flow (current US$) in Botswana in 1992 to that in 1994?
Provide a short and direct response. 0.45. What is the ratio of the Aid flow (current US$) of Djibouti in 1992 to that in 1994?
Ensure brevity in your answer.  1.76. What is the ratio of the Aid flow (current US$) in Suriname in 1992 to that in 1994?
Your answer should be very brief. 2.52. What is the ratio of the Aid flow (current US$) in Swaziland in 1992 to that in 1994?
Ensure brevity in your answer.  0.85. What is the ratio of the Aid flow (current US$) in Botswana in 1993 to that in 1994?
Your response must be concise. 1.84. What is the ratio of the Aid flow (current US$) of Djibouti in 1993 to that in 1994?
Offer a terse response. 1.72. What is the ratio of the Aid flow (current US$) of Suriname in 1993 to that in 1994?
Keep it short and to the point. 1.09. What is the ratio of the Aid flow (current US$) in Swaziland in 1993 to that in 1994?
Your response must be concise. 0.5. What is the difference between the highest and the second highest Aid flow (current US$) in Botswana?
Your response must be concise. 8.70e+06. What is the difference between the highest and the second highest Aid flow (current US$) in Djibouti?
Keep it short and to the point. 5.10e+05. What is the difference between the highest and the second highest Aid flow (current US$) in Suriname?
Keep it short and to the point. 1.67e+06. What is the difference between the highest and the second highest Aid flow (current US$) of Swaziland?
Your response must be concise. 1.18e+06. What is the difference between the highest and the lowest Aid flow (current US$) of Botswana?
Ensure brevity in your answer.  1.44e+07. What is the difference between the highest and the lowest Aid flow (current US$) in Djibouti?
Provide a succinct answer. 2.54e+06. What is the difference between the highest and the lowest Aid flow (current US$) of Suriname?
Your response must be concise. 8.63e+06. What is the difference between the highest and the lowest Aid flow (current US$) in Swaziland?
Your answer should be very brief. 4.88e+06. 